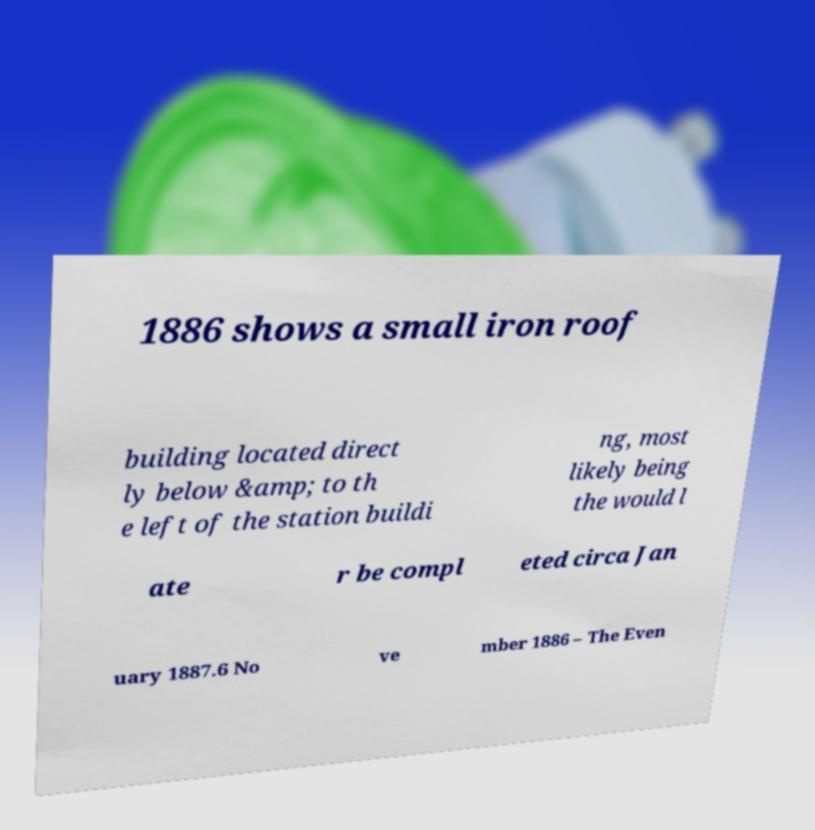There's text embedded in this image that I need extracted. Can you transcribe it verbatim? 1886 shows a small iron roof building located direct ly below &amp; to th e left of the station buildi ng, most likely being the would l ate r be compl eted circa Jan uary 1887.6 No ve mber 1886 – The Even 